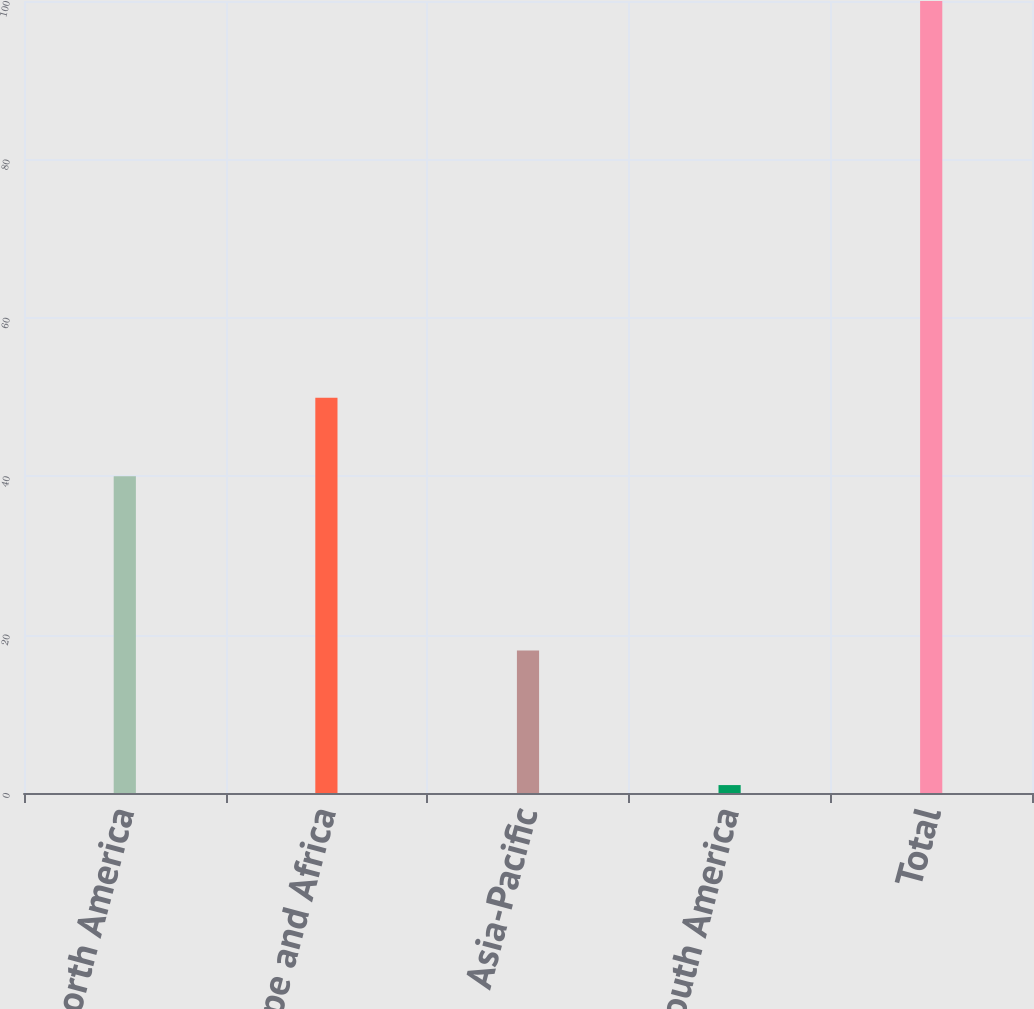Convert chart. <chart><loc_0><loc_0><loc_500><loc_500><bar_chart><fcel>North America<fcel>Europe and Africa<fcel>Asia-Pacific<fcel>South America<fcel>Total<nl><fcel>40<fcel>49.9<fcel>18<fcel>1<fcel>100<nl></chart> 